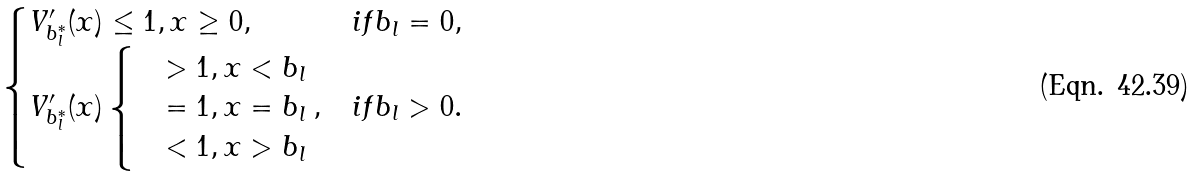<formula> <loc_0><loc_0><loc_500><loc_500>\begin{cases} { V } _ { b _ { l } ^ { * } } ^ { \prime } ( x ) \leq 1 , x \geq 0 , & i f b _ { l } = 0 , \\ { V } _ { b _ { l } ^ { * } } ^ { \prime } ( x ) \begin{cases} & > 1 , x < b _ { l } \\ & = 1 , x = b _ { l } \\ & < 1 , x > b _ { l } \end{cases} , & i f b _ { l } > 0 . \end{cases}</formula> 